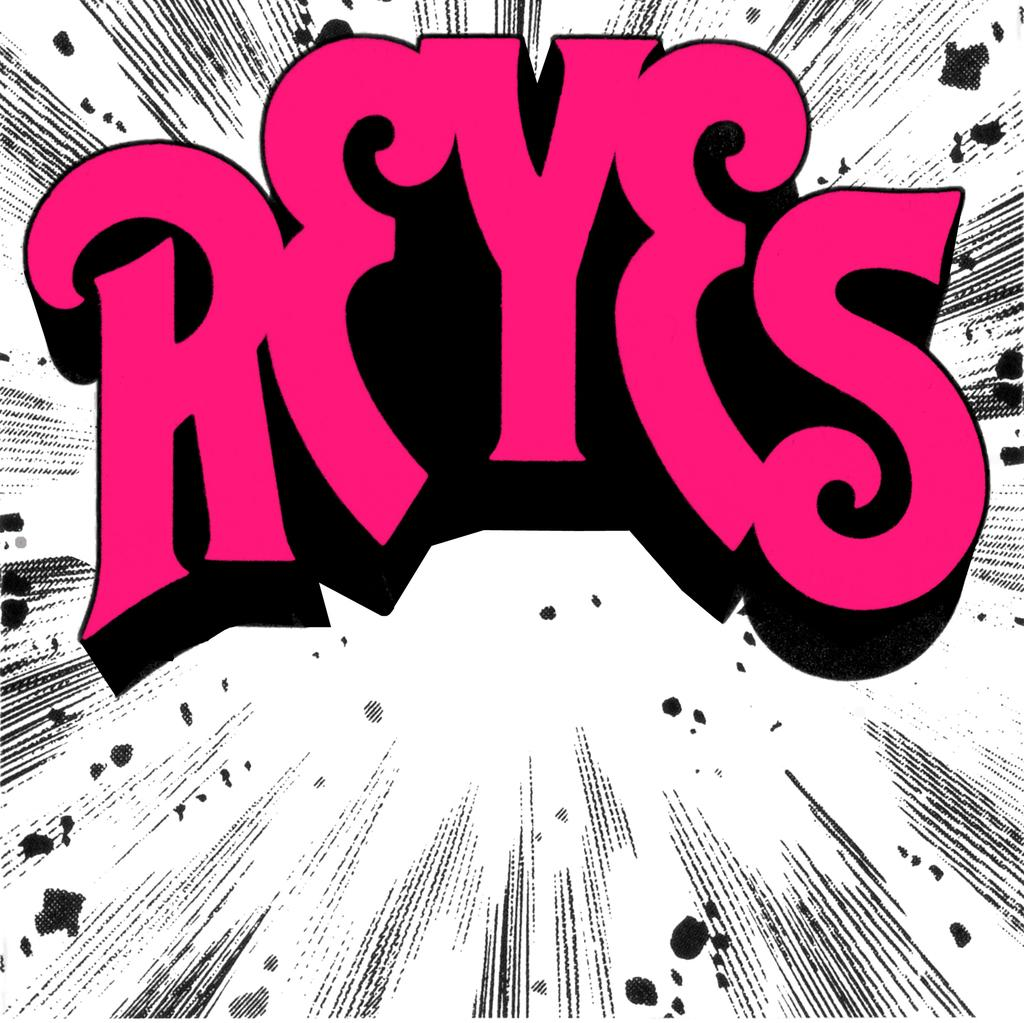<image>
Present a compact description of the photo's key features. A graphic of REYES in pink sits atop a black and white background. 